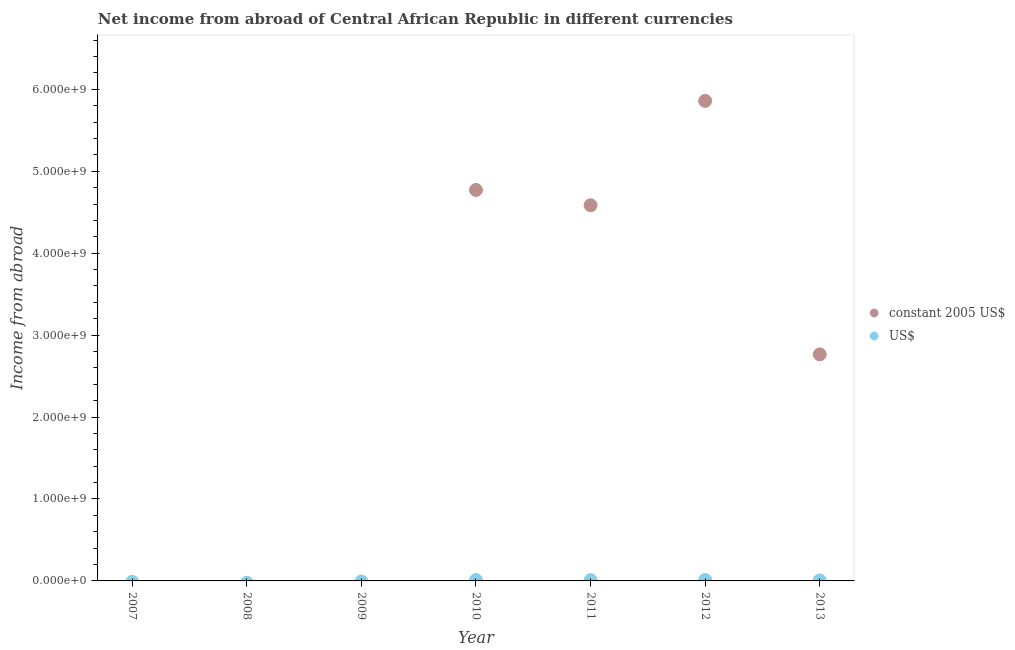What is the income from abroad in us$ in 2013?
Ensure brevity in your answer.  5.60e+06. Across all years, what is the maximum income from abroad in constant 2005 us$?
Ensure brevity in your answer.  5.86e+09. Across all years, what is the minimum income from abroad in us$?
Offer a very short reply. 0. In which year was the income from abroad in constant 2005 us$ maximum?
Give a very brief answer. 2012. What is the total income from abroad in us$ in the graph?
Keep it short and to the point. 3.64e+07. What is the difference between the income from abroad in us$ in 2010 and that in 2011?
Make the answer very short. -8.17e+04. What is the difference between the income from abroad in constant 2005 us$ in 2007 and the income from abroad in us$ in 2009?
Your answer should be very brief. 0. What is the average income from abroad in us$ per year?
Keep it short and to the point. 5.20e+06. In the year 2011, what is the difference between the income from abroad in constant 2005 us$ and income from abroad in us$?
Give a very brief answer. 4.57e+09. In how many years, is the income from abroad in constant 2005 us$ greater than 6200000000 units?
Your answer should be compact. 0. What is the ratio of the income from abroad in us$ in 2010 to that in 2011?
Your response must be concise. 0.99. Is the difference between the income from abroad in constant 2005 us$ in 2010 and 2012 greater than the difference between the income from abroad in us$ in 2010 and 2012?
Make the answer very short. No. What is the difference between the highest and the second highest income from abroad in constant 2005 us$?
Your response must be concise. 1.09e+09. What is the difference between the highest and the lowest income from abroad in constant 2005 us$?
Give a very brief answer. 5.86e+09. In how many years, is the income from abroad in constant 2005 us$ greater than the average income from abroad in constant 2005 us$ taken over all years?
Your answer should be compact. 4. Does the income from abroad in us$ monotonically increase over the years?
Give a very brief answer. No. Is the income from abroad in us$ strictly less than the income from abroad in constant 2005 us$ over the years?
Give a very brief answer. No. How many dotlines are there?
Your answer should be compact. 2. How many years are there in the graph?
Provide a short and direct response. 7. What is the difference between two consecutive major ticks on the Y-axis?
Provide a succinct answer. 1.00e+09. Are the values on the major ticks of Y-axis written in scientific E-notation?
Ensure brevity in your answer.  Yes. Does the graph contain any zero values?
Offer a very short reply. Yes. Where does the legend appear in the graph?
Ensure brevity in your answer.  Center right. How many legend labels are there?
Offer a terse response. 2. How are the legend labels stacked?
Provide a succinct answer. Vertical. What is the title of the graph?
Make the answer very short. Net income from abroad of Central African Republic in different currencies. Does "By country of origin" appear as one of the legend labels in the graph?
Offer a very short reply. No. What is the label or title of the Y-axis?
Ensure brevity in your answer.  Income from abroad. What is the Income from abroad in US$ in 2008?
Offer a terse response. 0. What is the Income from abroad of US$ in 2009?
Offer a terse response. 0. What is the Income from abroad of constant 2005 US$ in 2010?
Your answer should be compact. 4.77e+09. What is the Income from abroad of US$ in 2010?
Keep it short and to the point. 9.63e+06. What is the Income from abroad of constant 2005 US$ in 2011?
Your answer should be compact. 4.58e+09. What is the Income from abroad in US$ in 2011?
Offer a terse response. 9.72e+06. What is the Income from abroad of constant 2005 US$ in 2012?
Your response must be concise. 5.86e+09. What is the Income from abroad of US$ in 2012?
Give a very brief answer. 1.15e+07. What is the Income from abroad in constant 2005 US$ in 2013?
Ensure brevity in your answer.  2.76e+09. What is the Income from abroad in US$ in 2013?
Offer a very short reply. 5.60e+06. Across all years, what is the maximum Income from abroad of constant 2005 US$?
Your response must be concise. 5.86e+09. Across all years, what is the maximum Income from abroad in US$?
Provide a succinct answer. 1.15e+07. Across all years, what is the minimum Income from abroad in constant 2005 US$?
Keep it short and to the point. 0. Across all years, what is the minimum Income from abroad in US$?
Keep it short and to the point. 0. What is the total Income from abroad of constant 2005 US$ in the graph?
Keep it short and to the point. 1.80e+1. What is the total Income from abroad in US$ in the graph?
Provide a succinct answer. 3.64e+07. What is the difference between the Income from abroad in constant 2005 US$ in 2010 and that in 2011?
Ensure brevity in your answer.  1.87e+08. What is the difference between the Income from abroad of US$ in 2010 and that in 2011?
Give a very brief answer. -8.17e+04. What is the difference between the Income from abroad of constant 2005 US$ in 2010 and that in 2012?
Give a very brief answer. -1.09e+09. What is the difference between the Income from abroad of US$ in 2010 and that in 2012?
Keep it short and to the point. -1.84e+06. What is the difference between the Income from abroad of constant 2005 US$ in 2010 and that in 2013?
Ensure brevity in your answer.  2.01e+09. What is the difference between the Income from abroad of US$ in 2010 and that in 2013?
Offer a very short reply. 4.04e+06. What is the difference between the Income from abroad in constant 2005 US$ in 2011 and that in 2012?
Offer a terse response. -1.27e+09. What is the difference between the Income from abroad in US$ in 2011 and that in 2012?
Give a very brief answer. -1.76e+06. What is the difference between the Income from abroad of constant 2005 US$ in 2011 and that in 2013?
Offer a very short reply. 1.82e+09. What is the difference between the Income from abroad of US$ in 2011 and that in 2013?
Keep it short and to the point. 4.12e+06. What is the difference between the Income from abroad of constant 2005 US$ in 2012 and that in 2013?
Give a very brief answer. 3.09e+09. What is the difference between the Income from abroad in US$ in 2012 and that in 2013?
Provide a succinct answer. 5.88e+06. What is the difference between the Income from abroad in constant 2005 US$ in 2010 and the Income from abroad in US$ in 2011?
Your answer should be very brief. 4.76e+09. What is the difference between the Income from abroad in constant 2005 US$ in 2010 and the Income from abroad in US$ in 2012?
Offer a very short reply. 4.76e+09. What is the difference between the Income from abroad of constant 2005 US$ in 2010 and the Income from abroad of US$ in 2013?
Offer a terse response. 4.77e+09. What is the difference between the Income from abroad in constant 2005 US$ in 2011 and the Income from abroad in US$ in 2012?
Give a very brief answer. 4.57e+09. What is the difference between the Income from abroad of constant 2005 US$ in 2011 and the Income from abroad of US$ in 2013?
Offer a very short reply. 4.58e+09. What is the difference between the Income from abroad of constant 2005 US$ in 2012 and the Income from abroad of US$ in 2013?
Offer a very short reply. 5.85e+09. What is the average Income from abroad in constant 2005 US$ per year?
Give a very brief answer. 2.57e+09. What is the average Income from abroad of US$ per year?
Your response must be concise. 5.20e+06. In the year 2010, what is the difference between the Income from abroad in constant 2005 US$ and Income from abroad in US$?
Your response must be concise. 4.76e+09. In the year 2011, what is the difference between the Income from abroad in constant 2005 US$ and Income from abroad in US$?
Offer a very short reply. 4.57e+09. In the year 2012, what is the difference between the Income from abroad in constant 2005 US$ and Income from abroad in US$?
Provide a succinct answer. 5.85e+09. In the year 2013, what is the difference between the Income from abroad in constant 2005 US$ and Income from abroad in US$?
Your response must be concise. 2.76e+09. What is the ratio of the Income from abroad of constant 2005 US$ in 2010 to that in 2011?
Offer a terse response. 1.04. What is the ratio of the Income from abroad in US$ in 2010 to that in 2011?
Your answer should be compact. 0.99. What is the ratio of the Income from abroad of constant 2005 US$ in 2010 to that in 2012?
Your response must be concise. 0.81. What is the ratio of the Income from abroad in US$ in 2010 to that in 2012?
Offer a terse response. 0.84. What is the ratio of the Income from abroad in constant 2005 US$ in 2010 to that in 2013?
Provide a short and direct response. 1.73. What is the ratio of the Income from abroad in US$ in 2010 to that in 2013?
Provide a succinct answer. 1.72. What is the ratio of the Income from abroad in constant 2005 US$ in 2011 to that in 2012?
Offer a terse response. 0.78. What is the ratio of the Income from abroad in US$ in 2011 to that in 2012?
Your response must be concise. 0.85. What is the ratio of the Income from abroad of constant 2005 US$ in 2011 to that in 2013?
Your answer should be very brief. 1.66. What is the ratio of the Income from abroad in US$ in 2011 to that in 2013?
Provide a short and direct response. 1.74. What is the ratio of the Income from abroad in constant 2005 US$ in 2012 to that in 2013?
Provide a short and direct response. 2.12. What is the ratio of the Income from abroad of US$ in 2012 to that in 2013?
Provide a succinct answer. 2.05. What is the difference between the highest and the second highest Income from abroad of constant 2005 US$?
Your answer should be very brief. 1.09e+09. What is the difference between the highest and the second highest Income from abroad of US$?
Offer a very short reply. 1.76e+06. What is the difference between the highest and the lowest Income from abroad in constant 2005 US$?
Make the answer very short. 5.86e+09. What is the difference between the highest and the lowest Income from abroad of US$?
Give a very brief answer. 1.15e+07. 